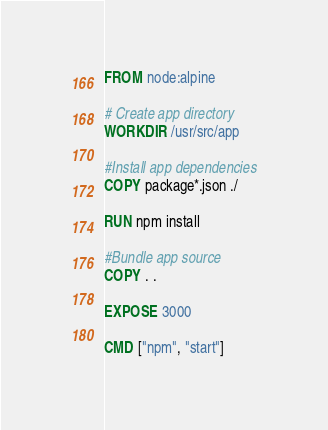Convert code to text. <code><loc_0><loc_0><loc_500><loc_500><_Dockerfile_>FROM node:alpine

# Create app directory
WORKDIR /usr/src/app

#Install app dependencies
COPY package*.json ./

RUN npm install

#Bundle app source
COPY . .

EXPOSE 3000

CMD ["npm", "start"]</code> 